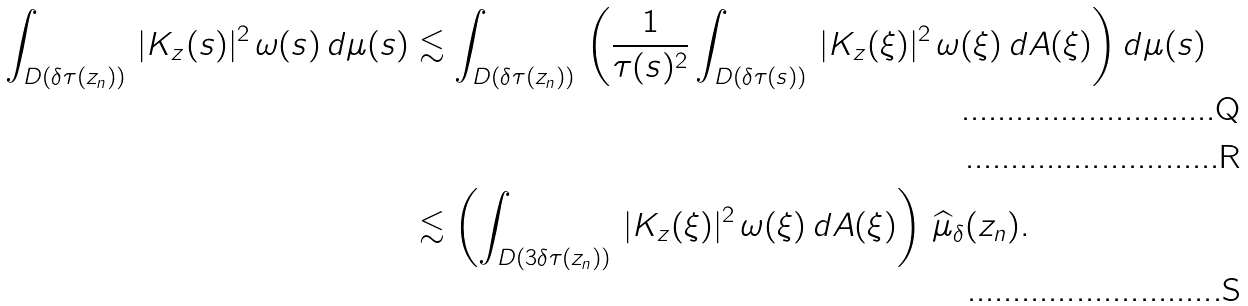<formula> <loc_0><loc_0><loc_500><loc_500>\int _ { D ( \delta \tau ( z _ { n } ) ) } \, | K _ { z } ( s ) | ^ { 2 } \, \omega ( s ) \, d \mu ( s ) & \lesssim \int _ { D ( \delta \tau ( z _ { n } ) ) } \, \left ( \frac { 1 } { \tau ( s ) ^ { 2 } } \int _ { D ( \delta \tau ( s ) ) } \, | K _ { z } ( \xi ) | ^ { 2 } \, \omega ( \xi ) \, d A ( \xi ) \right ) d \mu ( s ) \\ \\ & \lesssim \left ( \int _ { D ( 3 \delta \tau ( z _ { n } ) ) } \, | K _ { z } ( \xi ) | ^ { 2 } \, \omega ( \xi ) \, d A ( \xi ) \right ) \, \widehat { \mu } _ { \delta } ( z _ { n } ) .</formula> 